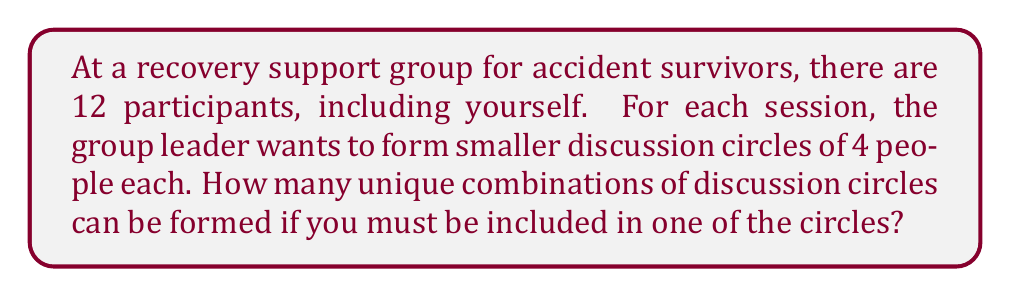What is the answer to this math problem? Let's approach this step-by-step:

1) First, we need to consider that you must be in one of the circles. This means we're essentially choosing 3 other people to be in your circle.

2) We can calculate this using the combination formula:
   $$\binom{11}{3} = \frac{11!}{3!(11-3)!} = \frac{11!}{3!8!}$$

3) Let's calculate this:
   $$\frac{11 * 10 * 9 * 8!}{(3 * 2 * 1) * 8!} = \frac{990}{6} = 165$$

4) So there are 165 ways to form your circle.

5) Now, for the remaining 8 people, we need to form 2 more circles of 4 each.

6) This is equivalent to dividing 8 people into 2 groups of 4, which can be done in:
   $$\frac{1}{2!} * \binom{8}{4} = \frac{1}{2} * \frac{8!}{4!(8-4)!} = \frac{1}{2} * \frac{8!}{4!4!}$$

7) Let's calculate this:
   $$\frac{1}{2} * \frac{8 * 7 * 6 * 5}{4 * 3 * 2 * 1} = \frac{1680}{48} = 35$$

8) By the multiplication principle, the total number of unique combinations is:
   $$165 * 35 = 5,775$$
Answer: 5,775 